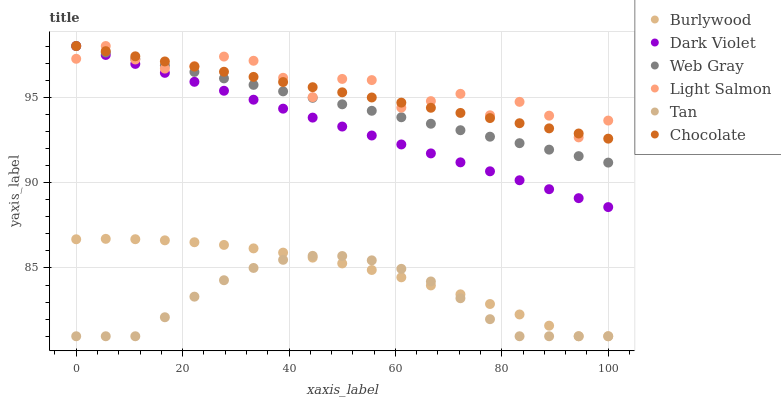Does Tan have the minimum area under the curve?
Answer yes or no. Yes. Does Light Salmon have the maximum area under the curve?
Answer yes or no. Yes. Does Web Gray have the minimum area under the curve?
Answer yes or no. No. Does Web Gray have the maximum area under the curve?
Answer yes or no. No. Is Dark Violet the smoothest?
Answer yes or no. Yes. Is Light Salmon the roughest?
Answer yes or no. Yes. Is Web Gray the smoothest?
Answer yes or no. No. Is Web Gray the roughest?
Answer yes or no. No. Does Burlywood have the lowest value?
Answer yes or no. Yes. Does Web Gray have the lowest value?
Answer yes or no. No. Does Chocolate have the highest value?
Answer yes or no. Yes. Does Burlywood have the highest value?
Answer yes or no. No. Is Tan less than Web Gray?
Answer yes or no. Yes. Is Web Gray greater than Burlywood?
Answer yes or no. Yes. Does Chocolate intersect Dark Violet?
Answer yes or no. Yes. Is Chocolate less than Dark Violet?
Answer yes or no. No. Is Chocolate greater than Dark Violet?
Answer yes or no. No. Does Tan intersect Web Gray?
Answer yes or no. No. 